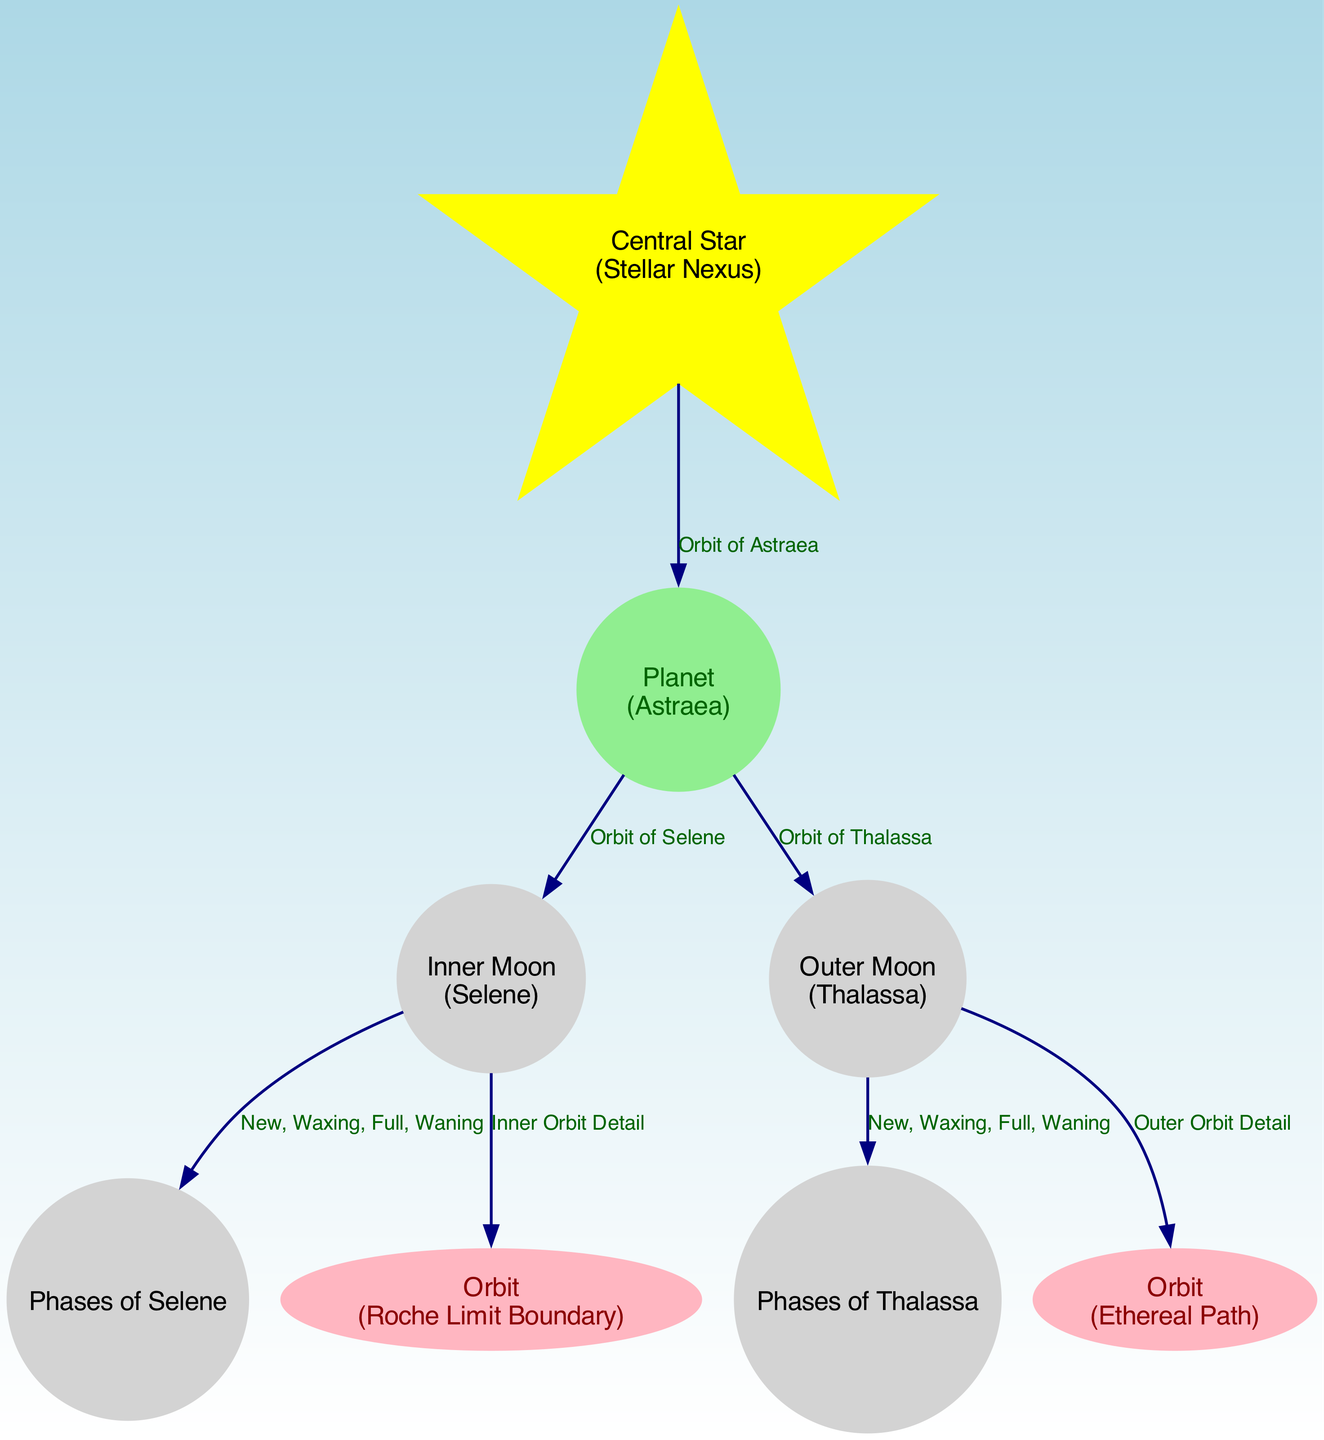What is the label of the central star? The label of the central star is found in the node marked as "central_star." It specifies "Central Star (Stellar Nexus)" as its name.
Answer: Central Star (Stellar Nexus) How many moons are depicted in the diagram? The diagram shows two moons: Selene (the inner moon) and Thalassa (the outer moon). Their labels can be counted in the nodes section.
Answer: 2 What does the inner moon orbit around? The inner moon, labeled as Selene, orbits the planet Astraea, as indicated by the edge connecting the two nodes.
Answer: Planet (Astraea) What are the phases of the Outer Moon? The phases of the outer moon are specified in the node labeled "outer_moon_phases," which lists "New, Waxing, Full, Waning." This information is directly connected to the outer moon node in the diagram.
Answer: New, Waxing, Full, Waning Which moon has an orbit labeled as "Roche Limit Boundary"? The inner moon, Selene, has an orbit that is specifically labeled as "Roche Limit Boundary.” This is indicated in the edge connecting the inner moon and the inner orbit node.
Answer: Selene What color represents the Central Star in the diagram? The Central Star is represented in yellow color, according to the custom node style applied to it. This can be inferred from the specific node attributes defined in the code.
Answer: Yellow What type of shape does the outer moon have? The outer moon, Thalassa, is represented as a circle in the diagram, based on the attributes specified for moon nodes in the visual representation.
Answer: Circle What are the two paths associated with the moons in the solar system? The two paths are the "Roche Limit Boundary" for the inner moon Selene and the "Ethereal Path" for the outer moon Thalassa, as described in their respective orbit nodes.
Answer: Roche Limit Boundary, Ethereal Path What is modeled in this diagram related to the orbit of Astraea? The diagram presents the path of the central star, which orbits around Astraea, depicted with the edge labeled "Orbit of Astraea." This directly highlights the spatial relationship in the diagram.
Answer: Orbit of Astraea 